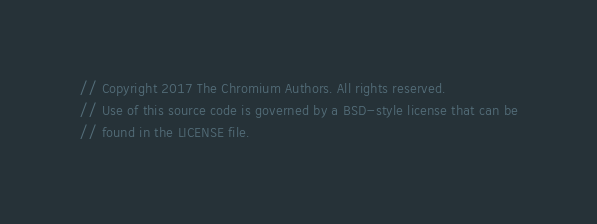Convert code to text. <code><loc_0><loc_0><loc_500><loc_500><_ObjectiveC_>// Copyright 2017 The Chromium Authors. All rights reserved.
// Use of this source code is governed by a BSD-style license that can be
// found in the LICENSE file.
</code> 